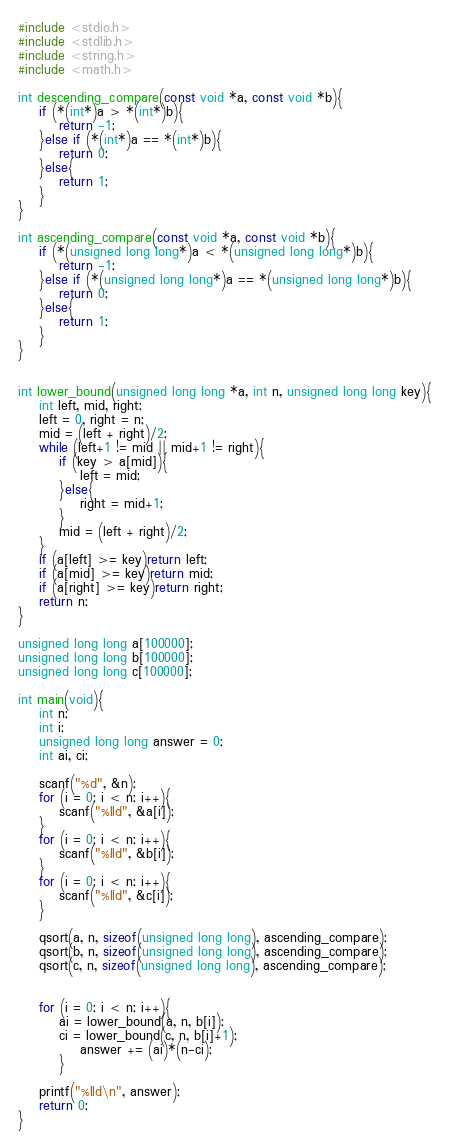<code> <loc_0><loc_0><loc_500><loc_500><_C_>#include <stdio.h>
#include <stdlib.h>
#include <string.h>
#include <math.h>

int descending_compare(const void *a, const void *b){
    if (*(int*)a > *(int*)b){
        return -1;
    }else if (*(int*)a == *(int*)b){
        return 0;
    }else{
        return 1;
    }
}

int ascending_compare(const void *a, const void *b){
    if (*(unsigned long long*)a < *(unsigned long long*)b){
        return -1;
    }else if (*(unsigned long long*)a == *(unsigned long long*)b){
        return 0;
    }else{
        return 1;
    }
}


int lower_bound(unsigned long long *a, int n, unsigned long long key){
    int left, mid, right;
    left = 0, right = n;
    mid = (left + right)/2;
    while (left+1 != mid || mid+1 != right){
        if (key > a[mid]){
            left = mid;
        }else{
            right = mid+1;
        }
        mid = (left + right)/2;
    }
    if (a[left] >= key)return left;
    if (a[mid] >= key)return mid;
    if (a[right] >= key)return right;
    return n;
}

unsigned long long a[100000];
unsigned long long b[100000];
unsigned long long c[100000];

int main(void){
    int n;
    int i;
    unsigned long long answer = 0;
    int ai, ci;
    
    scanf("%d", &n);
    for (i = 0; i < n; i++){
        scanf("%lld", &a[i]);
    }
    for (i = 0; i < n; i++){
        scanf("%lld", &b[i]);
    }
    for (i = 0; i < n; i++){
        scanf("%lld", &c[i]);
    }

    qsort(a, n, sizeof(unsigned long long), ascending_compare);
    qsort(b, n, sizeof(unsigned long long), ascending_compare);
    qsort(c, n, sizeof(unsigned long long), ascending_compare);

    
    for (i = 0; i < n; i++){
        ai = lower_bound(a, n, b[i]);
        ci = lower_bound(c, n, b[i]+1);
            answer += (ai)*(n-ci);
        }

    printf("%lld\n", answer);
    return 0;
}
</code> 